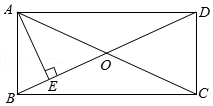What other geometric properties can be derived from observing the diagonals and their intersection? Observing the diagonals and their intersection point O can guide us in discovering several geometrical properties. Each diagonal divides the rectangle into two congruent right-angled triangles, such as triangles AOB and COD. The intersection at O also indicates that O is the midpoint of both diagonals. Moreover, these observations help deduce properties related to symmetry, area calculations, and angle properties which are integral in further geometrical constructions and theorems. 